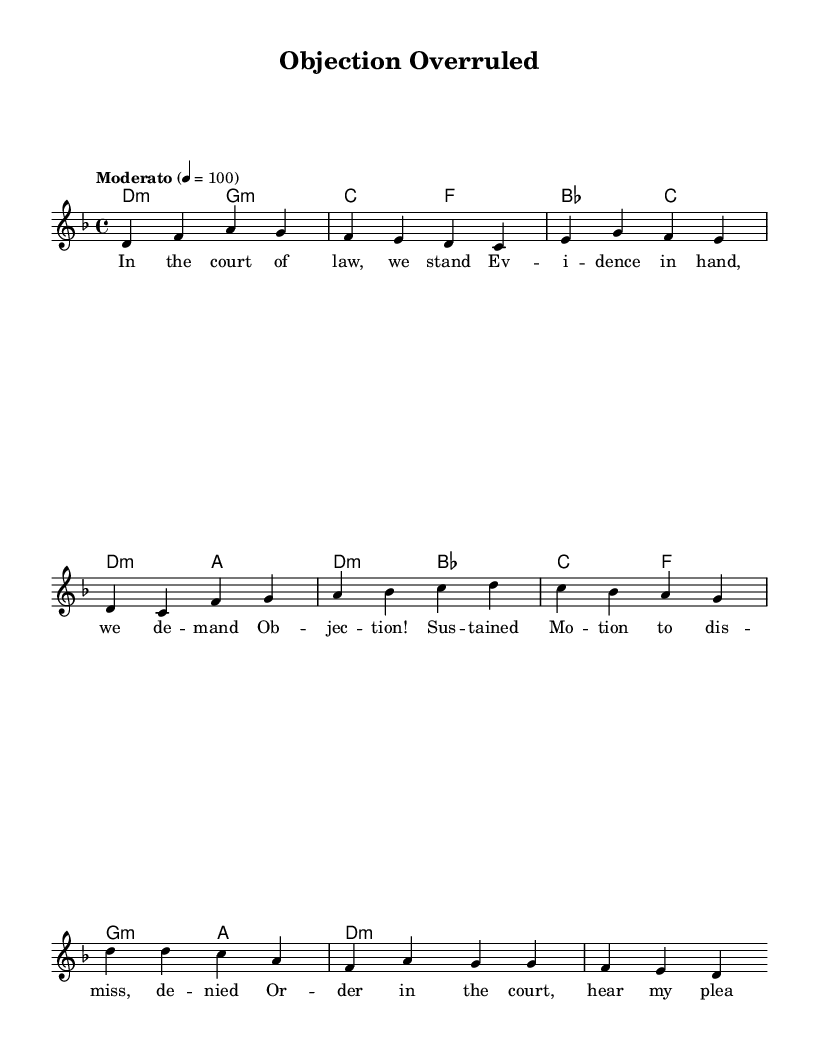What is the key signature of this music? The key signature is indicated by the number of sharps or flats at the beginning of the staff. In this case, the presence of a B-flat indicates that the key is D minor, which has one flat (B-flat).
Answer: D minor What is the time signature of this music? The time signature is found in the beginning of the piece and signifies the number of beats per measure. Here, the 4/4 time signature indicates that there are four beats in each measure.
Answer: 4/4 What is the tempo marking of this music? The tempo marking is usually specified with a descriptive term or beats per minute at the beginning of the score. In this case, it states "Moderato" with a tempo of 100 beats per minute.
Answer: Moderato What musical section comes after the verse in this song? The sections of the song are labeled, and after the verse, the next labeled section is the pre-chorus, which follows both in the structure of the song and the lyrics in the sheet music.
Answer: Pre-Chorus How many lines are in the chorus lyrics? To determine the number of lines in the chorus lyrics, we can count the distinct vocal lines provided in the lyrics section. The chorus consists of two lines of lyrics.
Answer: 2 Which legal term is repeated in the pre-chorus? The pre-chorus contains repeated legal terminology, specifically the word "Objection!" which signifies a legal challenge during court proceedings and is prominently featured in the lyrics.
Answer: Objection What is the overall theme of the song? The overall theme of the song can be discerned from the lyrics, which incorporate legal and courtroom terminology, implying a narrative about justice and standing in a courtroom, making it distinctly tied to legal themes.
Answer: Justice 